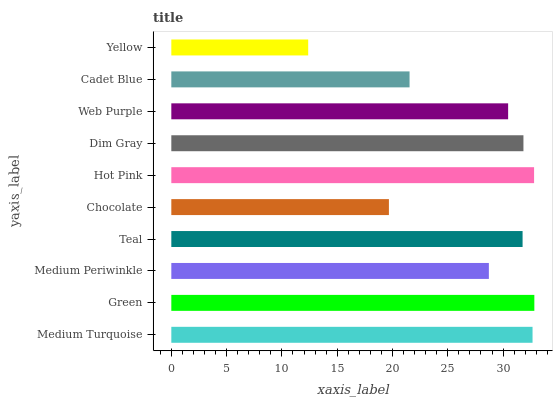Is Yellow the minimum?
Answer yes or no. Yes. Is Green the maximum?
Answer yes or no. Yes. Is Medium Periwinkle the minimum?
Answer yes or no. No. Is Medium Periwinkle the maximum?
Answer yes or no. No. Is Green greater than Medium Periwinkle?
Answer yes or no. Yes. Is Medium Periwinkle less than Green?
Answer yes or no. Yes. Is Medium Periwinkle greater than Green?
Answer yes or no. No. Is Green less than Medium Periwinkle?
Answer yes or no. No. Is Teal the high median?
Answer yes or no. Yes. Is Web Purple the low median?
Answer yes or no. Yes. Is Medium Turquoise the high median?
Answer yes or no. No. Is Dim Gray the low median?
Answer yes or no. No. 